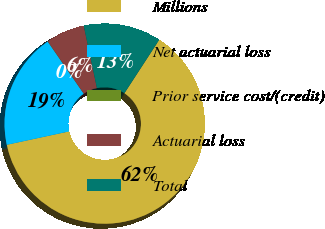Convert chart to OTSL. <chart><loc_0><loc_0><loc_500><loc_500><pie_chart><fcel>Millions<fcel>Net actuarial loss<fcel>Prior service cost/(credit)<fcel>Actuarial loss<fcel>Total<nl><fcel>62.43%<fcel>18.75%<fcel>0.03%<fcel>6.27%<fcel>12.51%<nl></chart> 